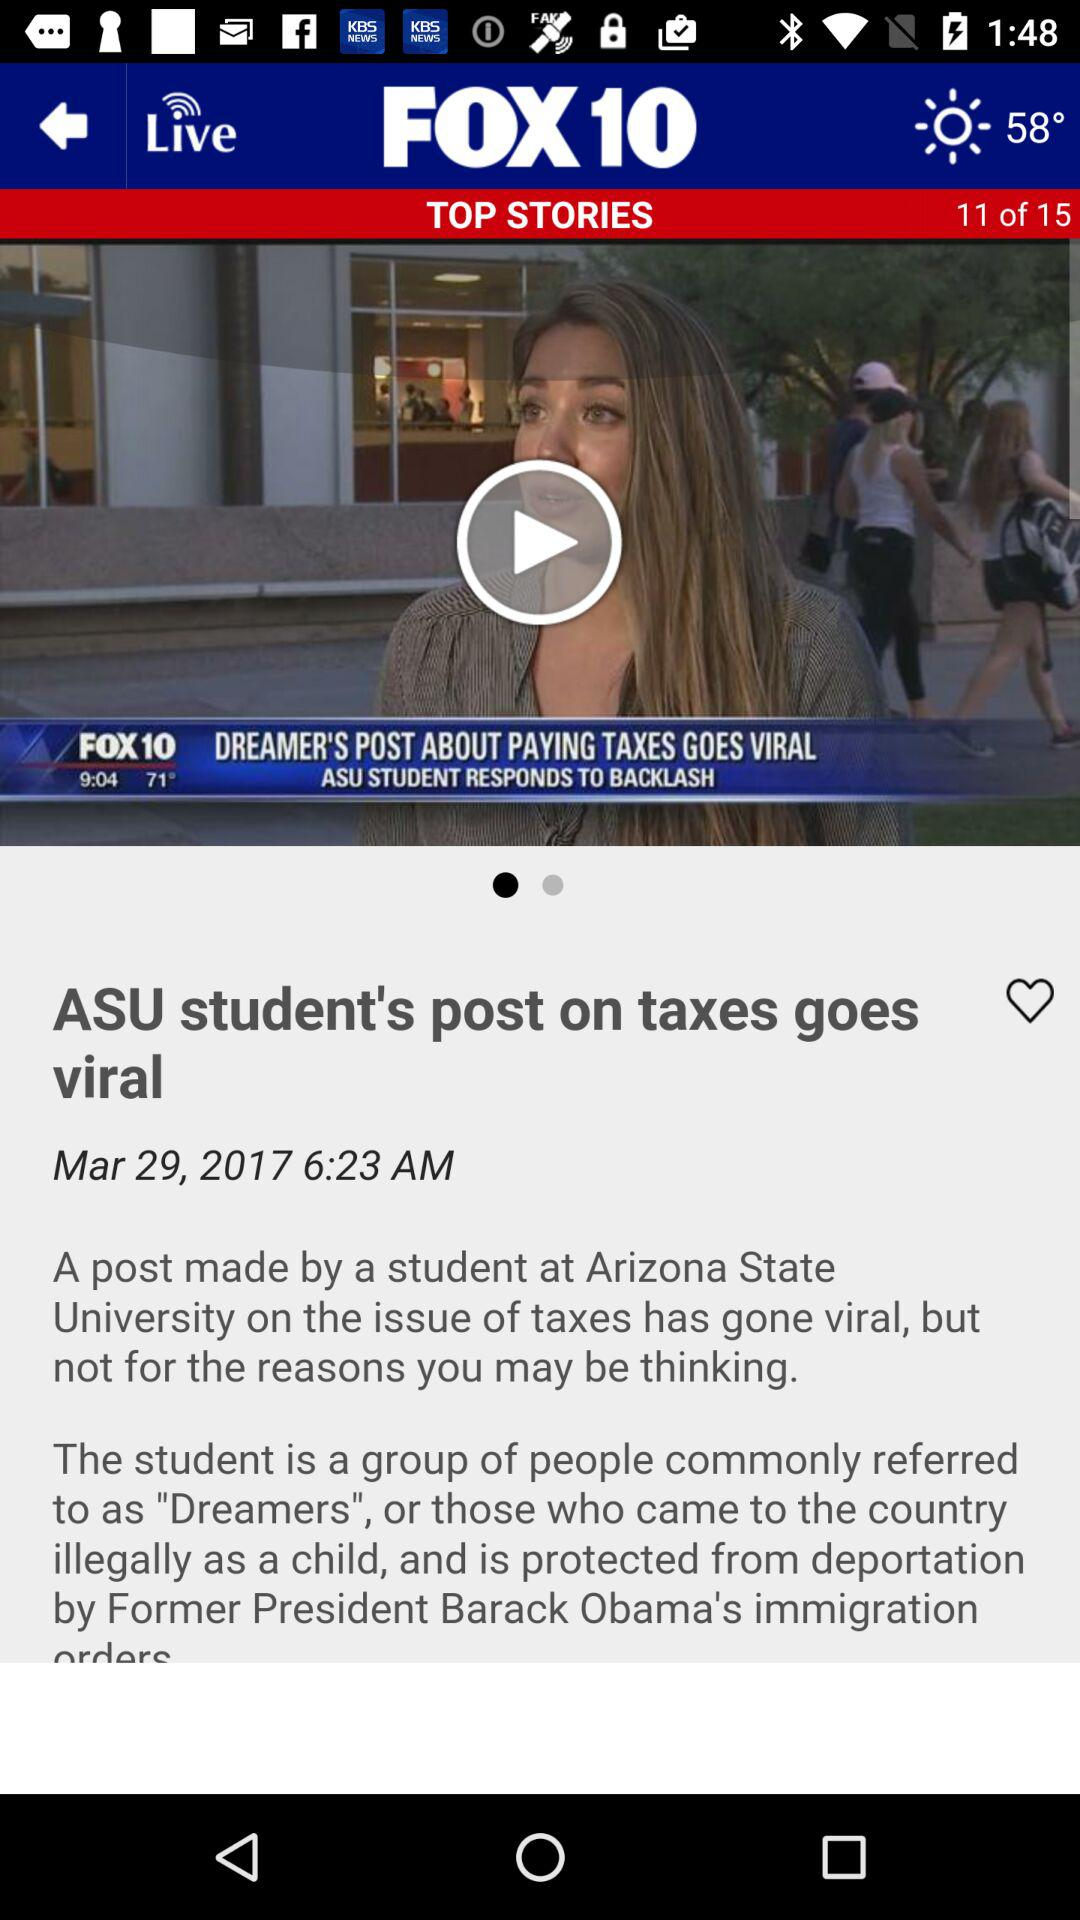What is the published time of the article? The published time is 6:23 AM. 